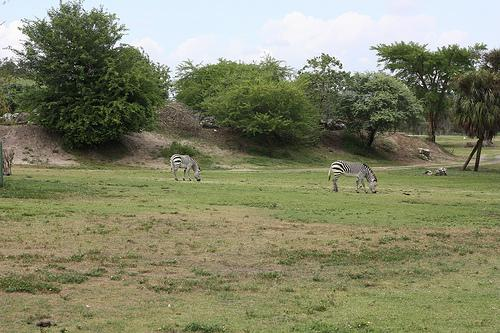Question: how many animals?
Choices:
A. Two.
B. One.
C. Three.
D. Four.
Answer with the letter. Answer: A Question: what are the animals?
Choices:
A. Elephants.
B. Cats.
C. Zebras.
D. Lions.
Answer with the letter. Answer: C Question: what are they doing?
Choices:
A. Hugging.
B. Kissing.
C. Eating.
D. Dancing.
Answer with the letter. Answer: C Question: where is the rainbow?
Choices:
A. Near the mountains.
B. To the north.
C. To the south.
D. No rainbow.
Answer with the letter. Answer: D Question: what is purple?
Choices:
A. The bus.
B. Nothing.
C. The shirt.
D. The hair.
Answer with the letter. Answer: B Question: who is swimming?
Choices:
A. A boy.
B. A girl.
C. No one.
D. A women.
Answer with the letter. Answer: C Question: why are they eating?
Choices:
A. Celebrating.
B. It is dinner time.
C. Hungry.
D. It is lunch time.
Answer with the letter. Answer: C 